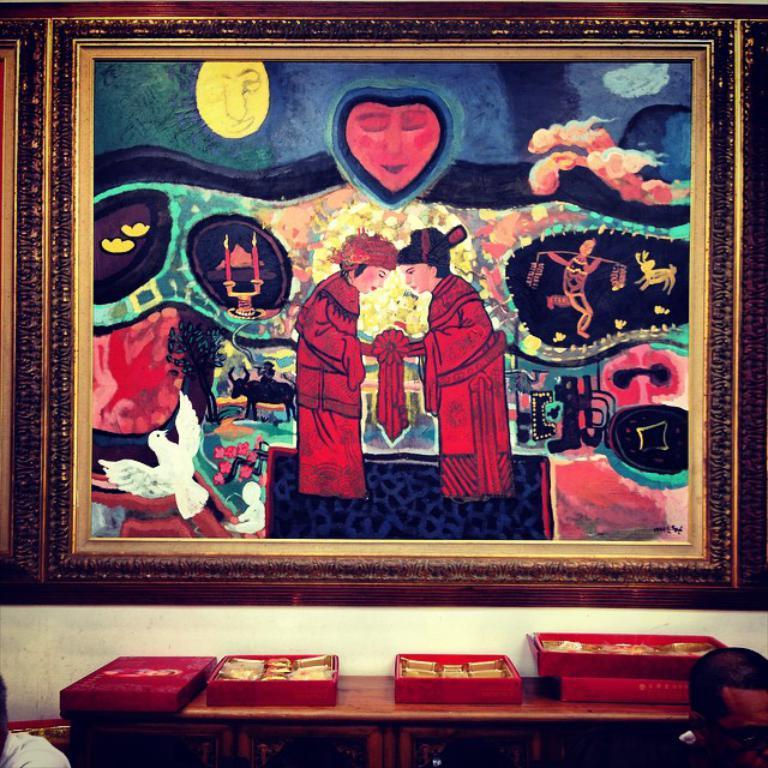Please provide a concise description of this image. This image consists of a wall painting, in which two persons are shaking their hands. Below that there is a table on which boxes are kept. And two persons are visible which are half visible. In the background there is a wall in white color. This image is taken inside a room. 